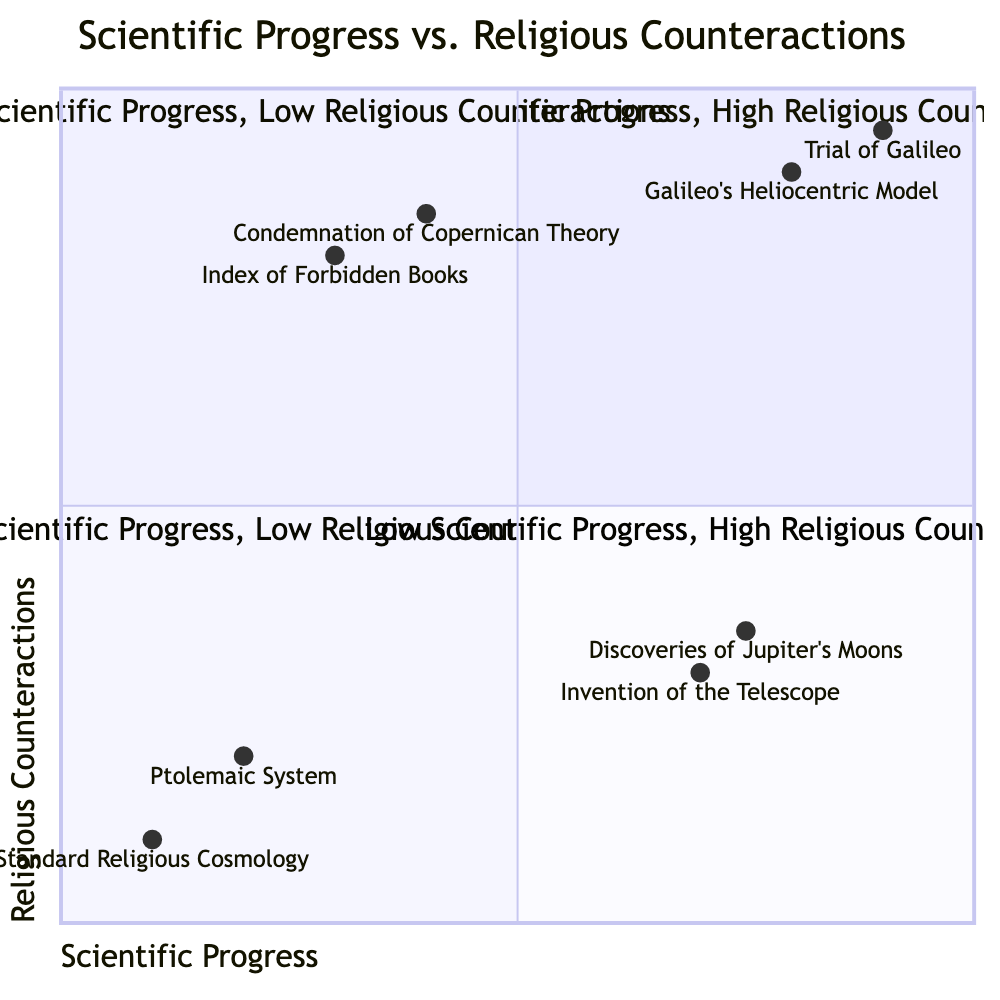What are the elements in Quadrant I? Quadrant I contains two elements: "Galileo's Heliocentric Model" and "Trial of Galileo." These elements focus on high scientific progress and high religious counteractions.
Answer: Galileo's Heliocentric Model, Trial of Galileo Which quadrant has the "Invention of the Telescope"? The "Invention of the Telescope" is located in Quadrant II, where there is high scientific progress and low religious counteractions.
Answer: Quadrant II What was Galileo's score on the x-axis? The score for Galileo's Heliocentric Model on the x-axis representing scientific progress is 0.8. This indicates a high level of scientific advancement associated with his work.
Answer: 0.8 How many elements are in Quadrant IV? Quadrant IV includes two elements: "Index of Forbidden Books" and "Condemnation of Copernican Theory." Therefore, there are a total of two elements in this quadrant.
Answer: 2 Explain the relationship between "Trial of Galileo" and "Condemnation of Copernican Theory". The "Trial of Galileo" and "Condemnation of Copernican Theory" both emphasize high religious counteractions against scientific progress. While the Trial of Galileo represents a direct response to Galileo's findings, the condemnation focuses on the rejection of the heliocentric model itself prior to his trial. Both activities illustrate the Church's resistance to scientific advancements.
Answer: Both high religious counteractions against scientific progress Which element has the highest score on the y-axis? The element with the highest score on the y-axis indicating religious counteractions is "Trial of Galileo," with a score of 0.95.
Answer: Trial of Galileo What is the category of the "Ptolemaic System"? The "Ptolemaic System" falls under Quadrant III, characterized by low scientific progress and low religious counteractions. This reflects a stable period where scientific inquiry was minimal and aligned with religious beliefs.
Answer: Quadrant III What does the Index of Forbidden Books represent? The Index of Forbidden Books represents high religious counteractions aimed at suppressing scientific works that contradict Church teachings, located in Quadrant IV.
Answer: High religious counteractions 